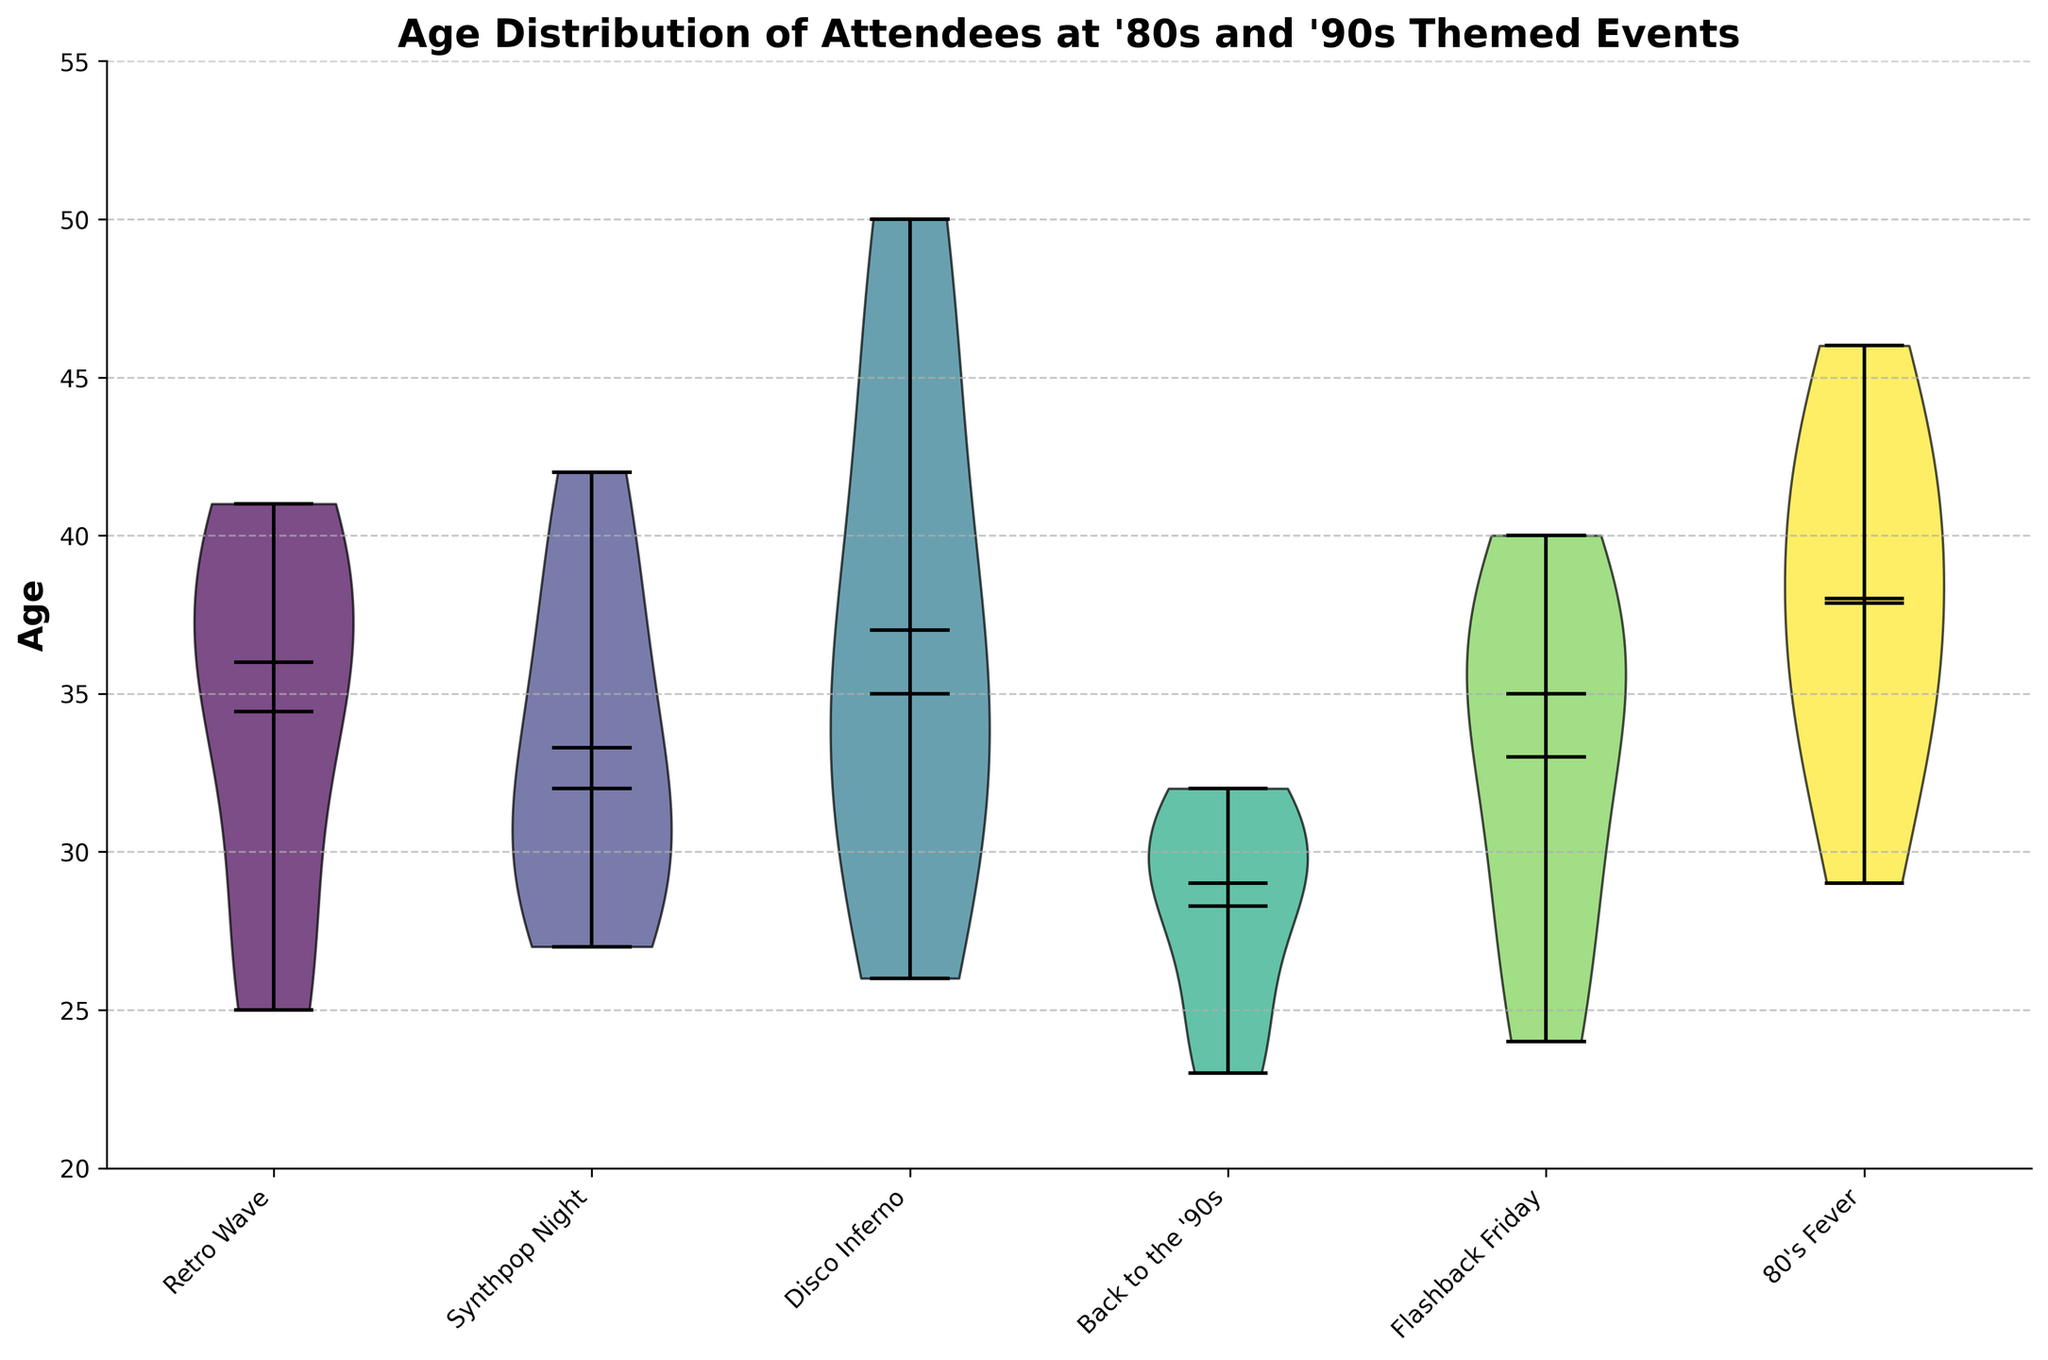What's the title of the figure? The title is displayed at the top of the figure, indicating the main topic or purpose of the plot.
Answer: Age Distribution of Attendees at '80s and '90s Themed Events Which city appears on the x-axis for the third event? The events are listed on the x-axis, organized by their order of appearance from left to right. The third event is "Disco Inferno."
Answer: Rio de Janeiro What is the median age of attendees for the "Back to the '90s" event? The violin plot for the "Back to the '90s" event shows a line crossing the middle of the violin. This line represents the median of the dataset.
Answer: 29 Which event has the highest average age of attendees? The mean is represented by a dot in the violin plot. For the event with the highest average age, the mean dot will be visibly higher than those of other events.
Answer: Disco Inferno How do the age distributions compare between "80's Fever" and "Retro Wave"? By examining the spread, shape, and other statistical markers like the median and mean in the violin plots, we can compare their age distributions. "Retro Wave" has a wider spread around the median compared to "80's Fever."
Answer: Retro Wave has a wider age distribution compared to 80's Fever What age range can be observed among attendees at "Synthpop Night"? The age range is visible by looking at the tails of the violin plot. The top edges represent the maximum age, and the bottom edges represent the minimum age in the dataset for that event.
Answer: 27-42 Which event has the narrowest range of ages among its attendees? The event with the narrowest range will have the most compact violin plot, with minimal spread from top to bottom.
Answer: Back to the '90s Is the mean age higher or lower than the median age for "Flashback Friday"? By comparing the dot (mean) and the line (median) in the violin plot for "Flashback Friday," we can determine their relative positions.
Answer: Higher How does the variability in ages for "Disco Inferno" compare to "80's Fever"? Variability is indicated by the spread of the violin plot. The wider the plot, the more variability. "Disco Inferno" shows a greater spread than "80's Fever."
Answer: Disco Inferno has greater variability What is the approximate range of ages for "Retro Wave"? This can be answered by looking at the tails of the violin plot for "Retro Wave."
Answer: 25-41 